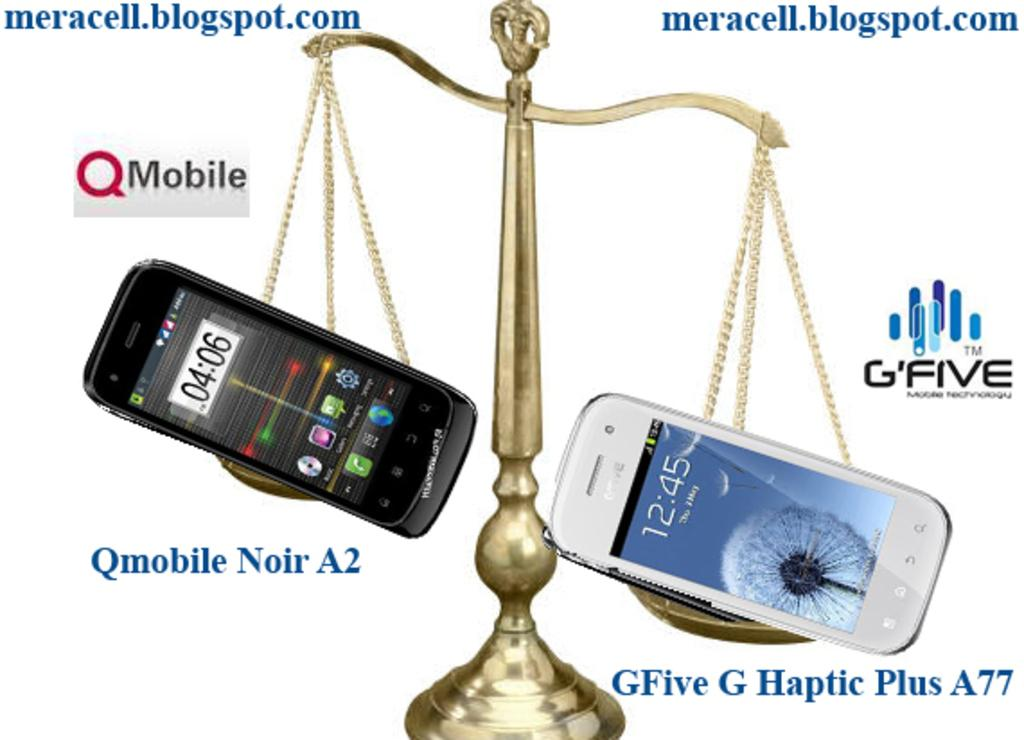<image>
Provide a brief description of the given image. Scale holding two phones and the word "QMobile" on the side. 